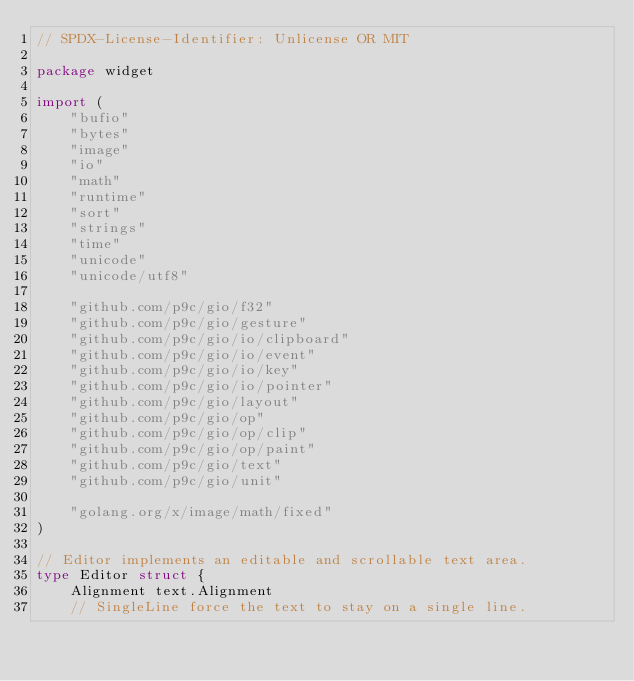<code> <loc_0><loc_0><loc_500><loc_500><_Go_>// SPDX-License-Identifier: Unlicense OR MIT

package widget

import (
	"bufio"
	"bytes"
	"image"
	"io"
	"math"
	"runtime"
	"sort"
	"strings"
	"time"
	"unicode"
	"unicode/utf8"

	"github.com/p9c/gio/f32"
	"github.com/p9c/gio/gesture"
	"github.com/p9c/gio/io/clipboard"
	"github.com/p9c/gio/io/event"
	"github.com/p9c/gio/io/key"
	"github.com/p9c/gio/io/pointer"
	"github.com/p9c/gio/layout"
	"github.com/p9c/gio/op"
	"github.com/p9c/gio/op/clip"
	"github.com/p9c/gio/op/paint"
	"github.com/p9c/gio/text"
	"github.com/p9c/gio/unit"

	"golang.org/x/image/math/fixed"
)

// Editor implements an editable and scrollable text area.
type Editor struct {
	Alignment text.Alignment
	// SingleLine force the text to stay on a single line.</code> 